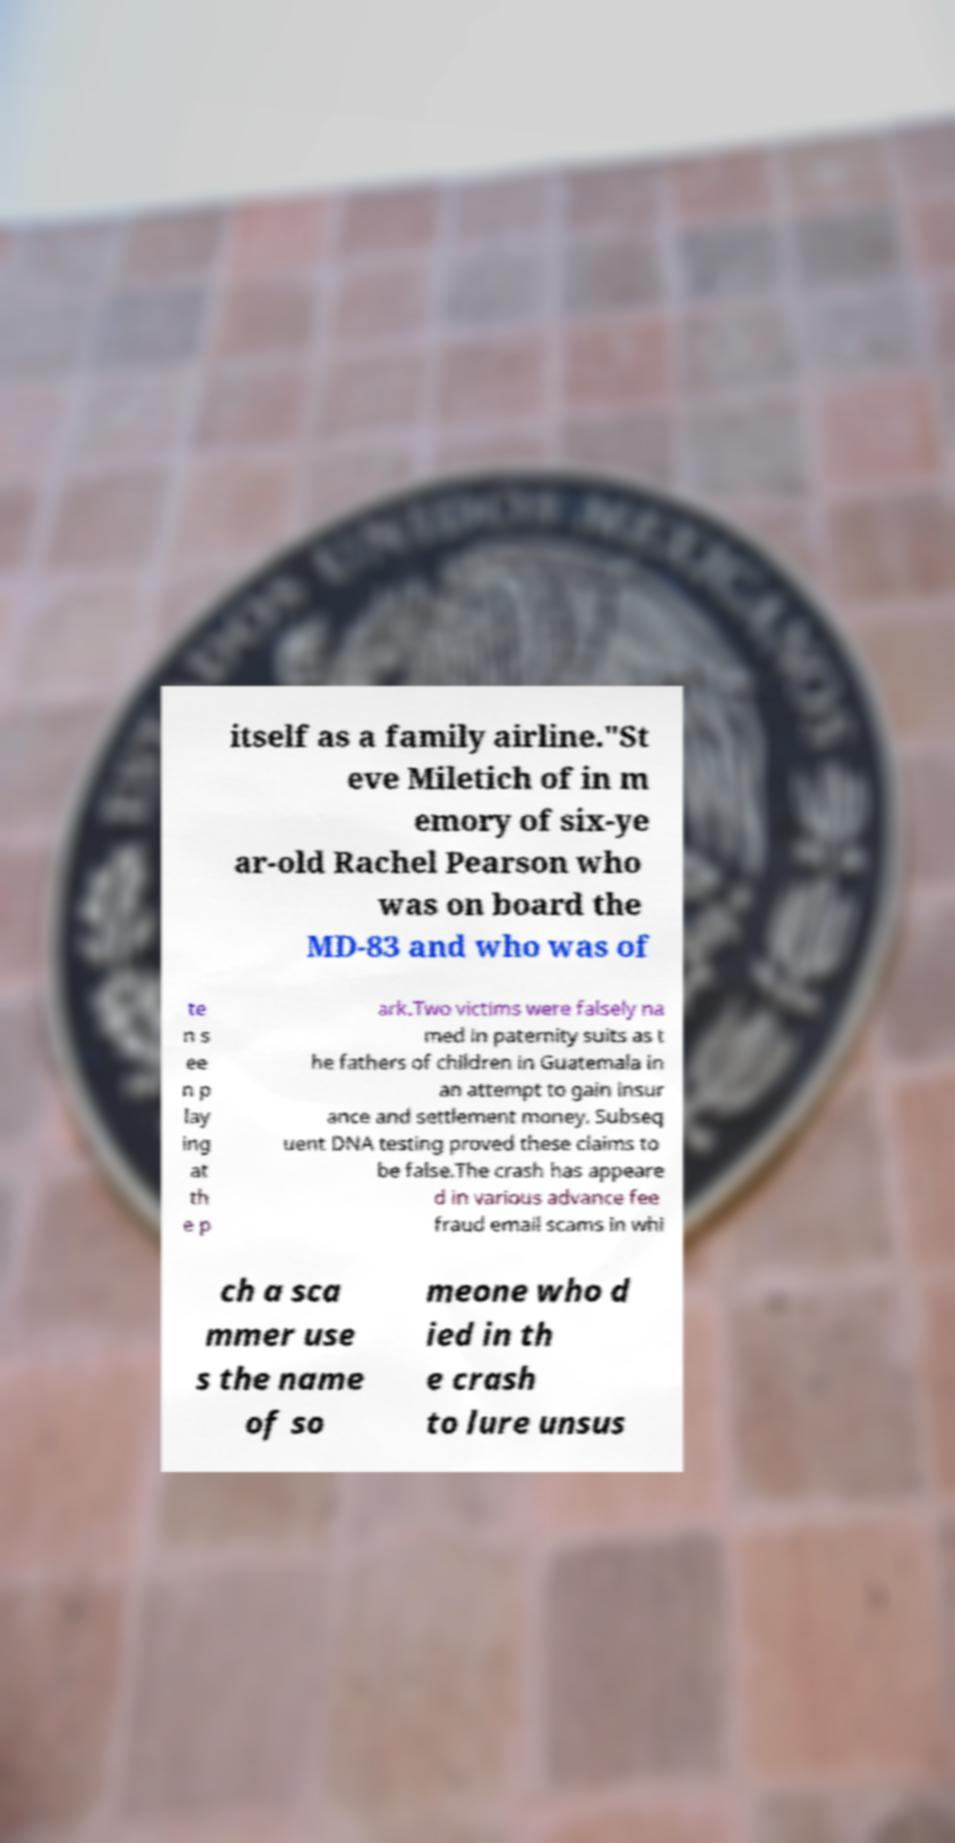Please identify and transcribe the text found in this image. itself as a family airline."St eve Miletich of in m emory of six-ye ar-old Rachel Pearson who was on board the MD-83 and who was of te n s ee n p lay ing at th e p ark.Two victims were falsely na med in paternity suits as t he fathers of children in Guatemala in an attempt to gain insur ance and settlement money. Subseq uent DNA testing proved these claims to be false.The crash has appeare d in various advance fee fraud email scams in whi ch a sca mmer use s the name of so meone who d ied in th e crash to lure unsus 